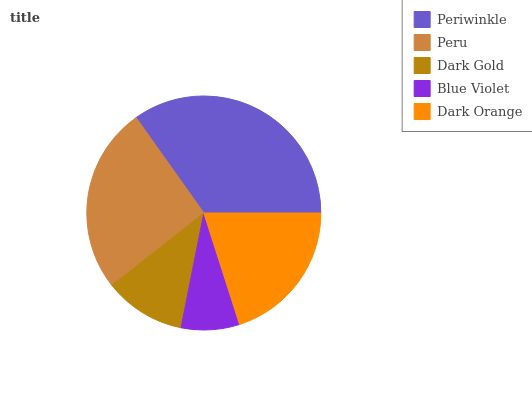Is Blue Violet the minimum?
Answer yes or no. Yes. Is Periwinkle the maximum?
Answer yes or no. Yes. Is Peru the minimum?
Answer yes or no. No. Is Peru the maximum?
Answer yes or no. No. Is Periwinkle greater than Peru?
Answer yes or no. Yes. Is Peru less than Periwinkle?
Answer yes or no. Yes. Is Peru greater than Periwinkle?
Answer yes or no. No. Is Periwinkle less than Peru?
Answer yes or no. No. Is Dark Orange the high median?
Answer yes or no. Yes. Is Dark Orange the low median?
Answer yes or no. Yes. Is Dark Gold the high median?
Answer yes or no. No. Is Dark Gold the low median?
Answer yes or no. No. 